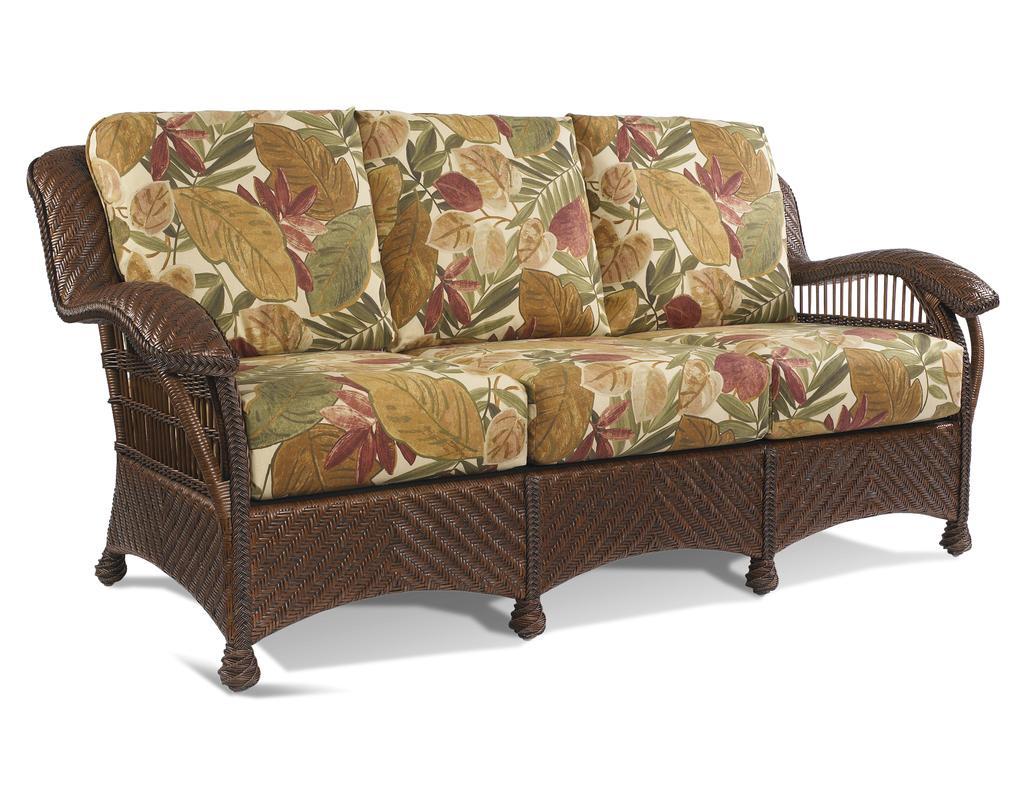How would you summarize this image in a sentence or two? This picture describes about a sofa. 